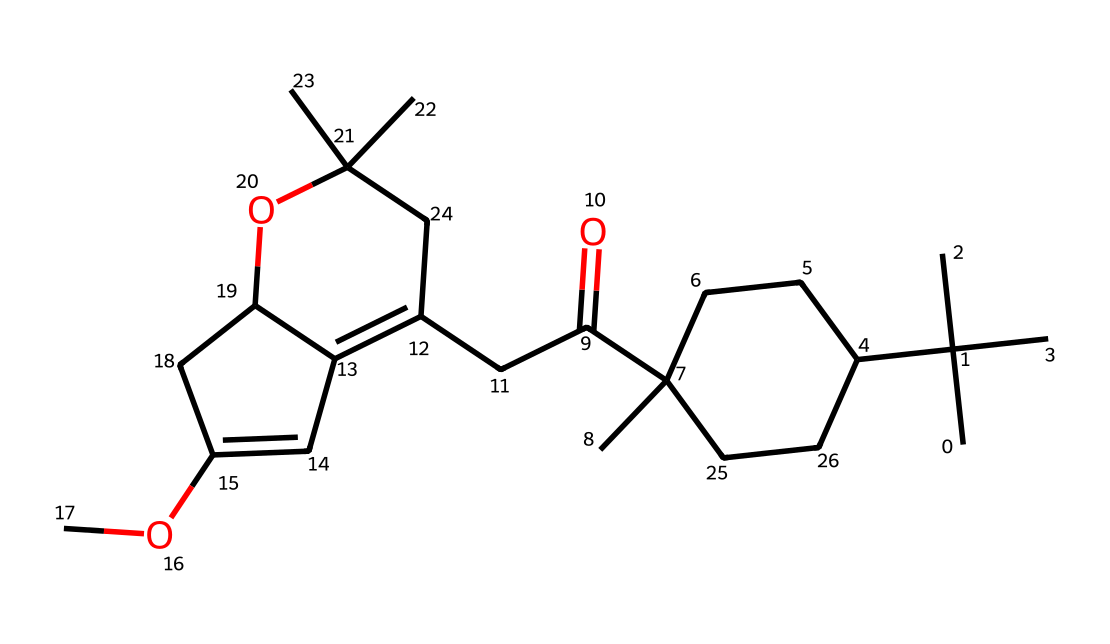What is the main functional group present in this chemical? The chemical contains a ketone functional group indicated by the presence of the carbonyl (C=O) bonded to two other carbon atoms.
Answer: ketone How many carbon atoms are in this molecule? By analyzing the SMILES representation, we can count a total of 27 carbon atoms indicated by the “C” symbols.
Answer: 27 What type of lipid does this chemical represent? This structure represents a class of lipids known as terpenoids or cannabinoids, as it is derived from the cannabis plant and fits their classification.
Answer: cannabinoids How many rings are present in this molecular structure? Observing the structure, there are two distinct cyclohexane-like rings visible in the chemical representation.
Answer: 2 What is the degree of unsaturation in this molecule? The degree of unsaturation can be determined by analyzing the structure's rings and double bonds; in this case, it has a degree of 6.
Answer: 6 What indicates that this chemical is hydrophobic? The long hydrocarbon tail and the absence of polar functional groups indicate its hydrophobic nature, which is typical for lipids.
Answer: hydrocarbon tail How does the presence of the ether groups affect the properties of this molecule? The presence of ether groups introduces some polarity, which can influence solubility in various solvents, but the overall structure remains predominantly hydrophobic.
Answer: slight polarity 